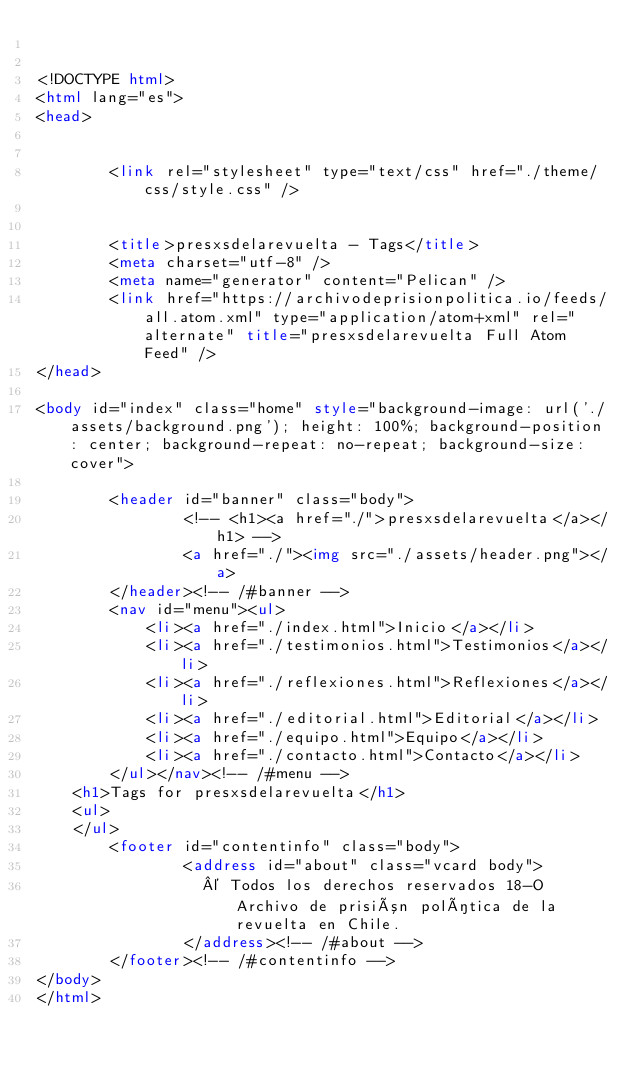Convert code to text. <code><loc_0><loc_0><loc_500><loc_500><_HTML_>

<!DOCTYPE html>
<html lang="es">
<head>

        
        <link rel="stylesheet" type="text/css" href="./theme/css/style.css" />
        

        <title>presxsdelarevuelta - Tags</title>
        <meta charset="utf-8" />
        <meta name="generator" content="Pelican" />
        <link href="https://archivodeprisionpolitica.io/feeds/all.atom.xml" type="application/atom+xml" rel="alternate" title="presxsdelarevuelta Full Atom Feed" />
</head>

<body id="index" class="home" style="background-image: url('./assets/background.png'); height: 100%; background-position: center; background-repeat: no-repeat; background-size: cover">
  
        <header id="banner" class="body">
                <!-- <h1><a href="./">presxsdelarevuelta</a></h1> -->
                <a href="./"><img src="./assets/header.png"></a>
        </header><!-- /#banner -->
        <nav id="menu"><ul>
            <li><a href="./index.html">Inicio</a></li>
            <li><a href="./testimonios.html">Testimonios</a></li>
            <li><a href="./reflexiones.html">Reflexiones</a></li>
            <li><a href="./editorial.html">Editorial</a></li>
            <li><a href="./equipo.html">Equipo</a></li>
            <li><a href="./contacto.html">Contacto</a></li>
        </ul></nav><!-- /#menu -->
    <h1>Tags for presxsdelarevuelta</h1>
    <ul>
    </ul>
        <footer id="contentinfo" class="body">
                <address id="about" class="vcard body">
                  © Todos los derechos reservados 18-O Archivo de prisión política de la revuelta en Chile.
                </address><!-- /#about -->
        </footer><!-- /#contentinfo -->
</body>
</html></code> 